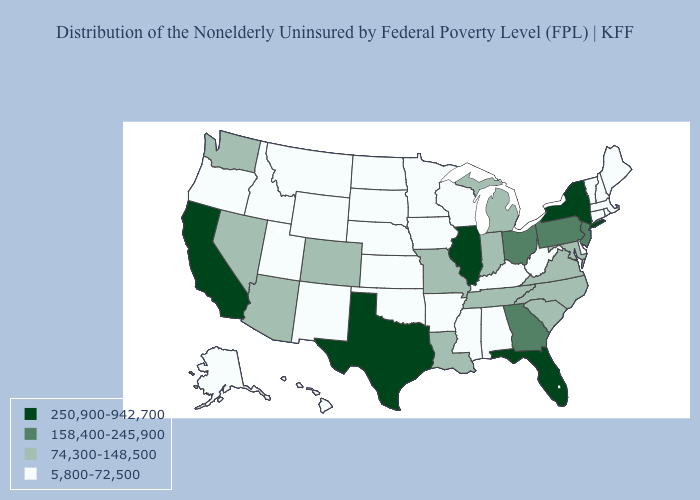How many symbols are there in the legend?
Give a very brief answer. 4. Among the states that border California , does Oregon have the lowest value?
Short answer required. Yes. Among the states that border Arizona , does New Mexico have the lowest value?
Give a very brief answer. Yes. Name the states that have a value in the range 158,400-245,900?
Give a very brief answer. Georgia, New Jersey, Ohio, Pennsylvania. Among the states that border Arizona , does California have the highest value?
Answer briefly. Yes. What is the value of Maryland?
Answer briefly. 74,300-148,500. Name the states that have a value in the range 158,400-245,900?
Be succinct. Georgia, New Jersey, Ohio, Pennsylvania. What is the value of New York?
Be succinct. 250,900-942,700. Name the states that have a value in the range 5,800-72,500?
Write a very short answer. Alabama, Alaska, Arkansas, Connecticut, Delaware, Hawaii, Idaho, Iowa, Kansas, Kentucky, Maine, Massachusetts, Minnesota, Mississippi, Montana, Nebraska, New Hampshire, New Mexico, North Dakota, Oklahoma, Oregon, Rhode Island, South Dakota, Utah, Vermont, West Virginia, Wisconsin, Wyoming. Which states have the lowest value in the USA?
Answer briefly. Alabama, Alaska, Arkansas, Connecticut, Delaware, Hawaii, Idaho, Iowa, Kansas, Kentucky, Maine, Massachusetts, Minnesota, Mississippi, Montana, Nebraska, New Hampshire, New Mexico, North Dakota, Oklahoma, Oregon, Rhode Island, South Dakota, Utah, Vermont, West Virginia, Wisconsin, Wyoming. What is the lowest value in states that border Florida?
Give a very brief answer. 5,800-72,500. How many symbols are there in the legend?
Answer briefly. 4. Which states have the lowest value in the USA?
Give a very brief answer. Alabama, Alaska, Arkansas, Connecticut, Delaware, Hawaii, Idaho, Iowa, Kansas, Kentucky, Maine, Massachusetts, Minnesota, Mississippi, Montana, Nebraska, New Hampshire, New Mexico, North Dakota, Oklahoma, Oregon, Rhode Island, South Dakota, Utah, Vermont, West Virginia, Wisconsin, Wyoming. What is the highest value in the USA?
Concise answer only. 250,900-942,700. What is the value of New York?
Quick response, please. 250,900-942,700. 